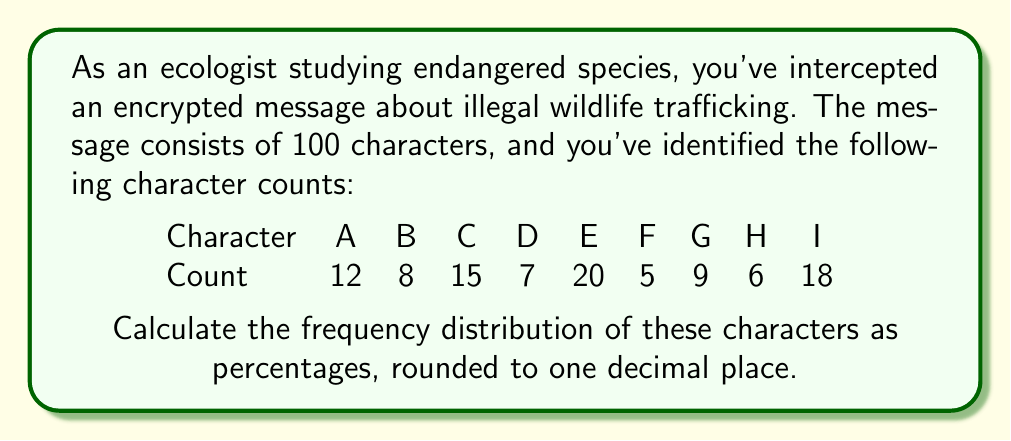Could you help me with this problem? To calculate the frequency distribution as percentages, we need to follow these steps:

1. Calculate the total number of characters:
   $12 + 8 + 15 + 7 + 20 + 5 + 9 + 6 + 18 = 100$ characters

2. For each character, calculate its frequency as a percentage:
   $\text{Frequency} (\%) = \frac{\text{Character count}}{\text{Total characters}} \times 100\%$

3. Calculate for each character:

   A: $\frac{12}{100} \times 100\% = 12.0\%$
   B: $\frac{8}{100} \times 100\% = 8.0\%$
   C: $\frac{15}{100} \times 100\% = 15.0\%$
   D: $\frac{7}{100} \times 100\% = 7.0\%$
   E: $\frac{20}{100} \times 100\% = 20.0\%$
   F: $\frac{5}{100} \times 100\% = 5.0\%$
   G: $\frac{9}{100} \times 100\% = 9.0\%$
   H: $\frac{6}{100} \times 100\% = 6.0\%$
   I: $\frac{18}{100} \times 100\% = 18.0\%$

4. Round each percentage to one decimal place (already done in this case).

The frequency distribution is now calculated as percentages for each character.
Answer: A: 12.0%, B: 8.0%, C: 15.0%, D: 7.0%, E: 20.0%, F: 5.0%, G: 9.0%, H: 6.0%, I: 18.0% 